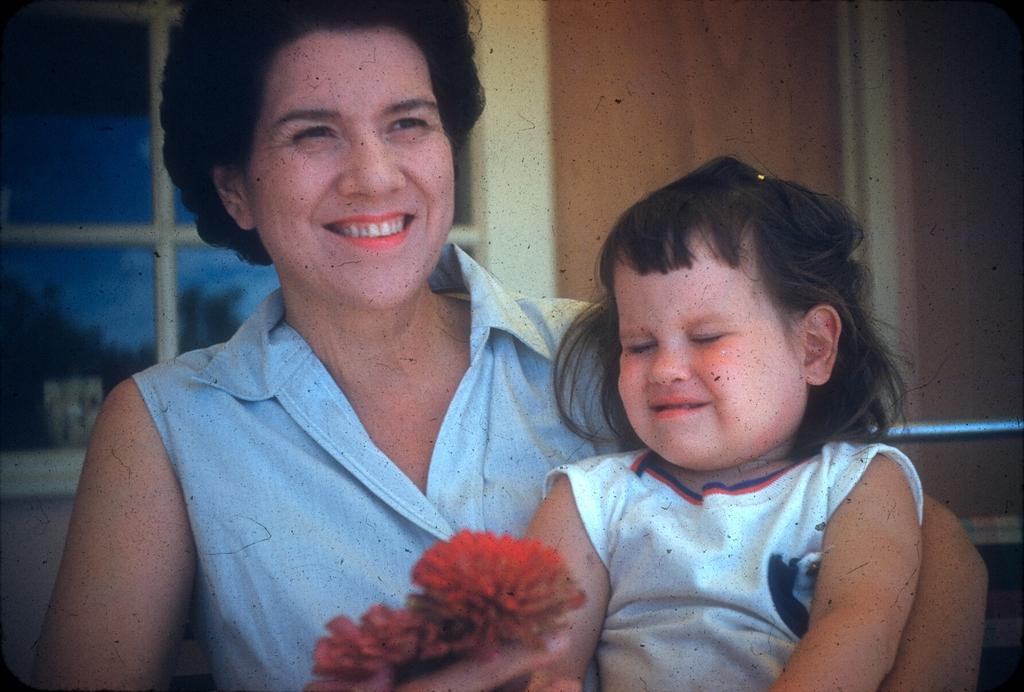Please provide a concise description of this image. In the center of the image we can see a lady is holding kid and flowers. In the background of the image we can see wall, window, glass, trees are there. 